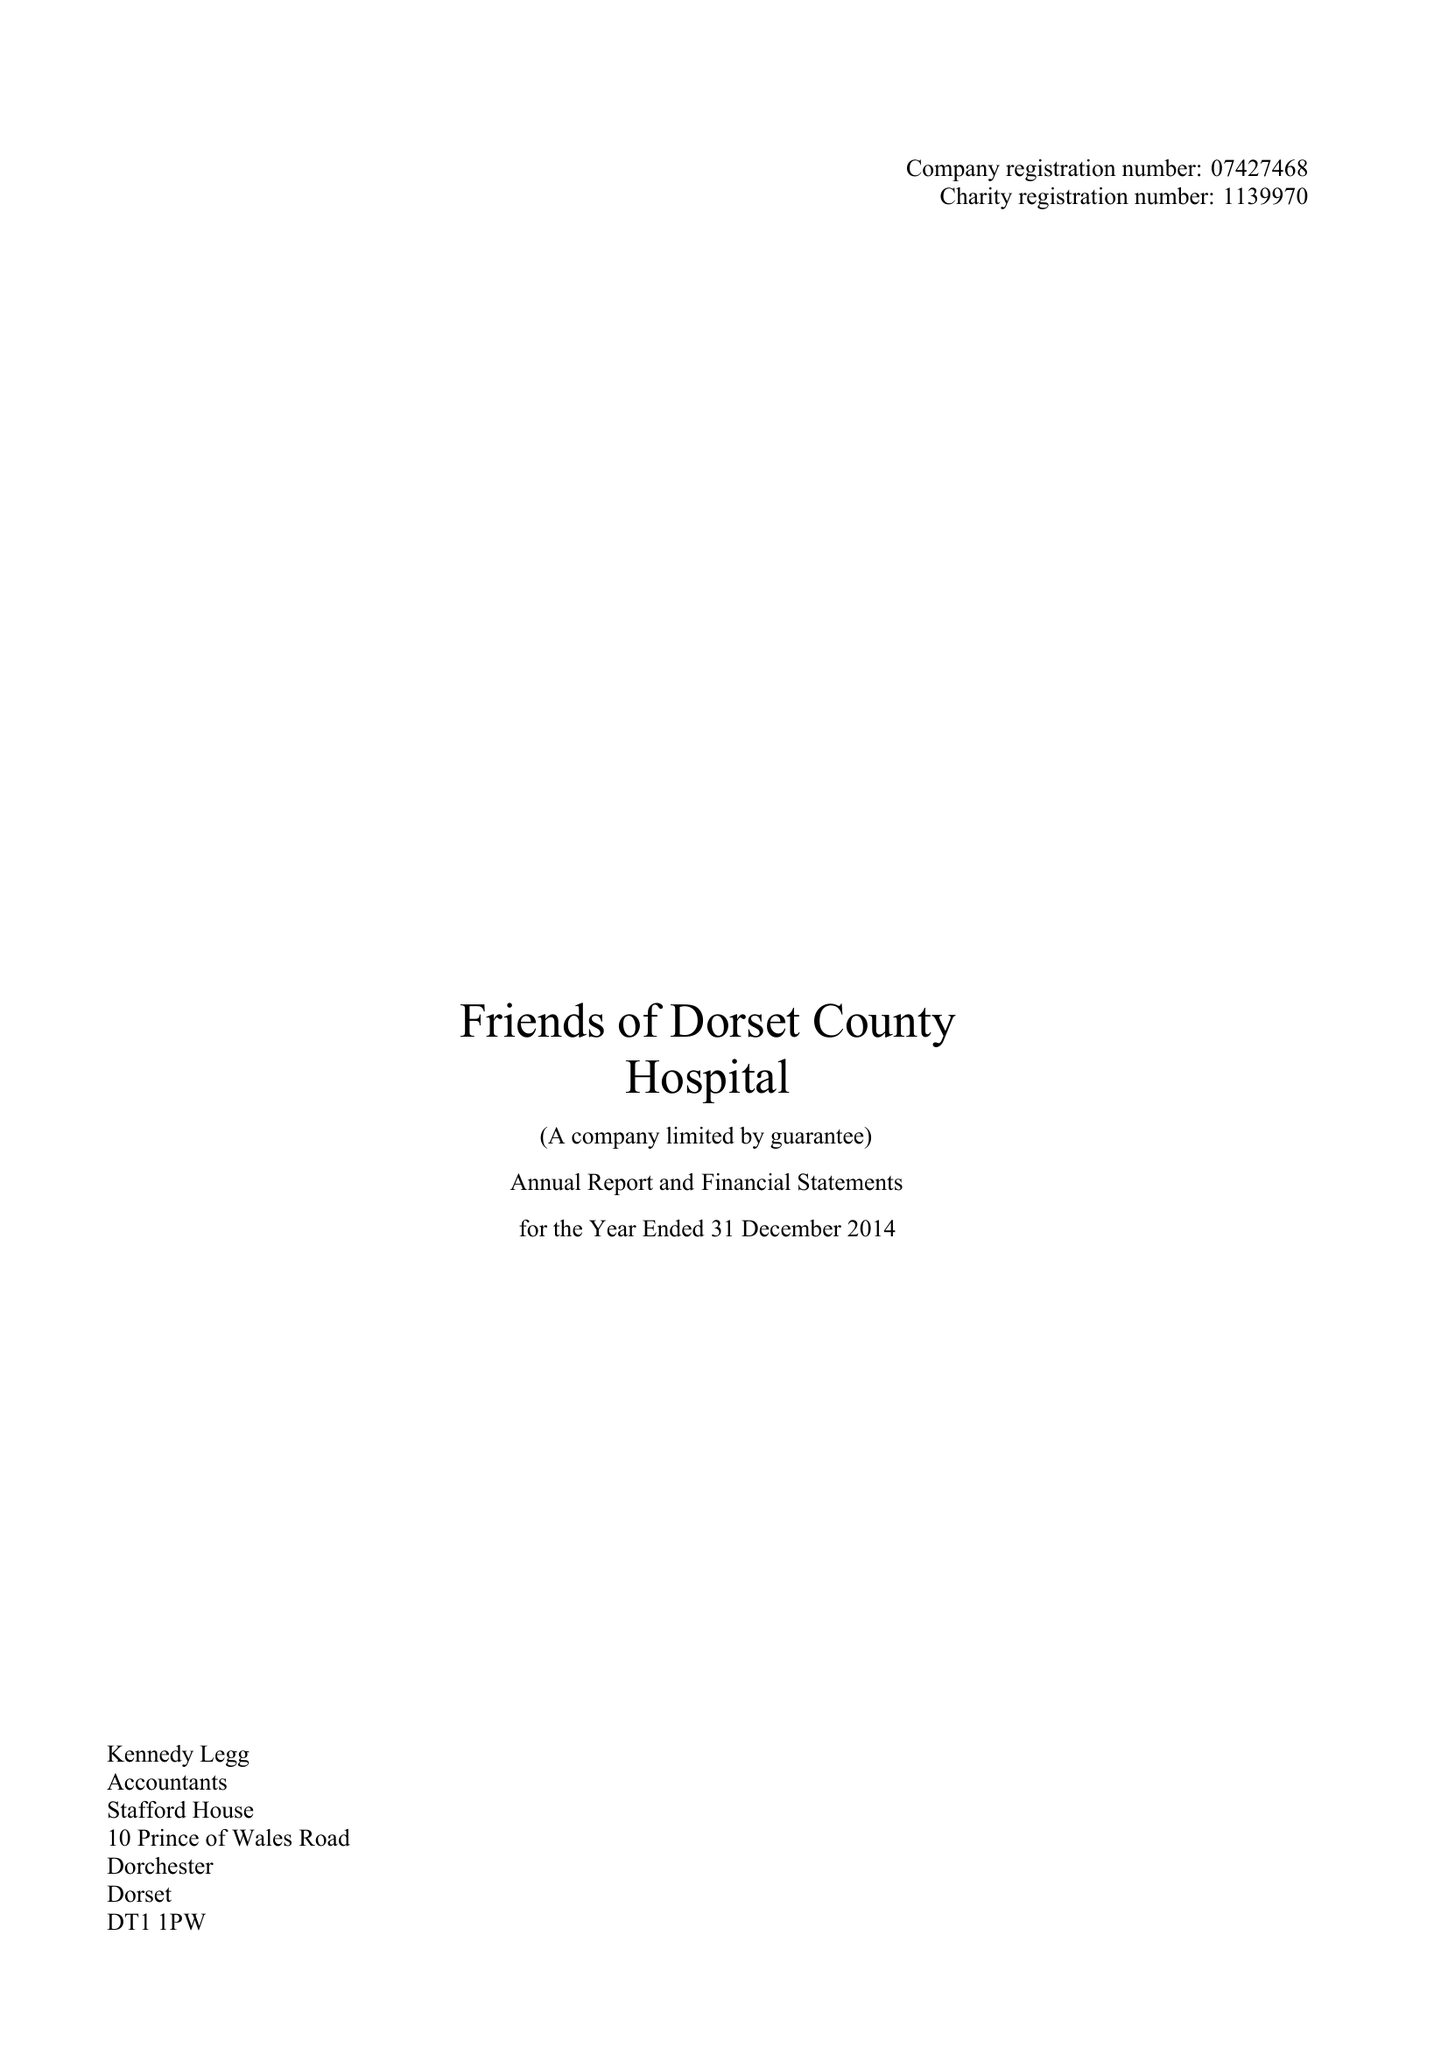What is the value for the income_annually_in_british_pounds?
Answer the question using a single word or phrase. 136169.00 